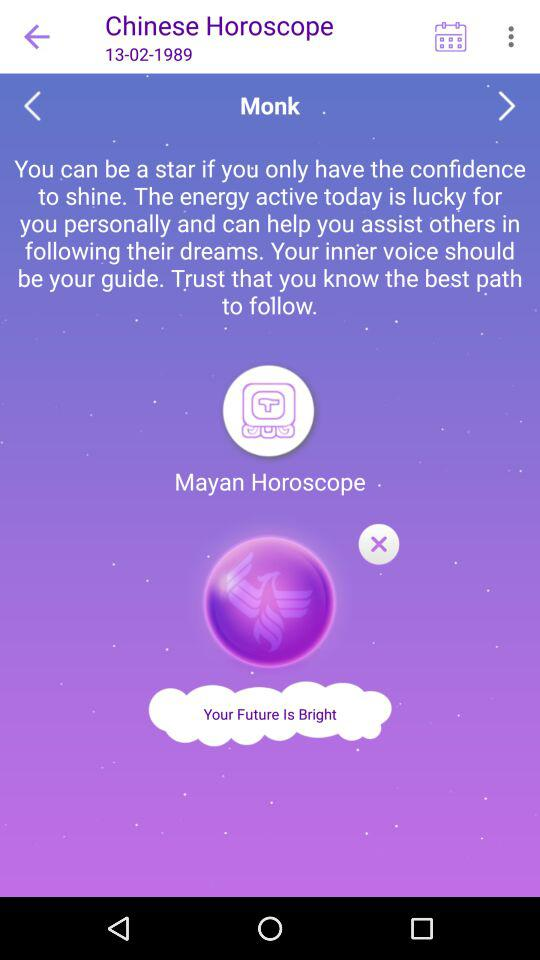What is the name of the application? The name of the application is "Chinese Horoscope". 